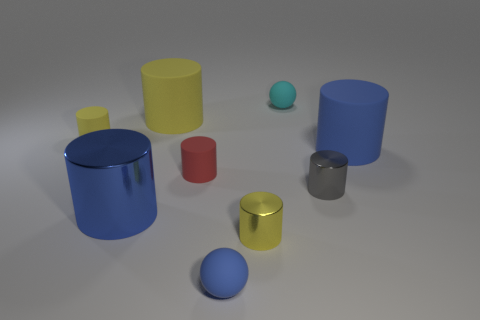What number of other objects are there of the same shape as the yellow metal object? Apart from the yellow cylinder, there are two other cylindrical objects in the image – one is blue and the other is red. Cylinders, characterized by their circular base and straight sides, are a common geometric shape found in various contexts. 